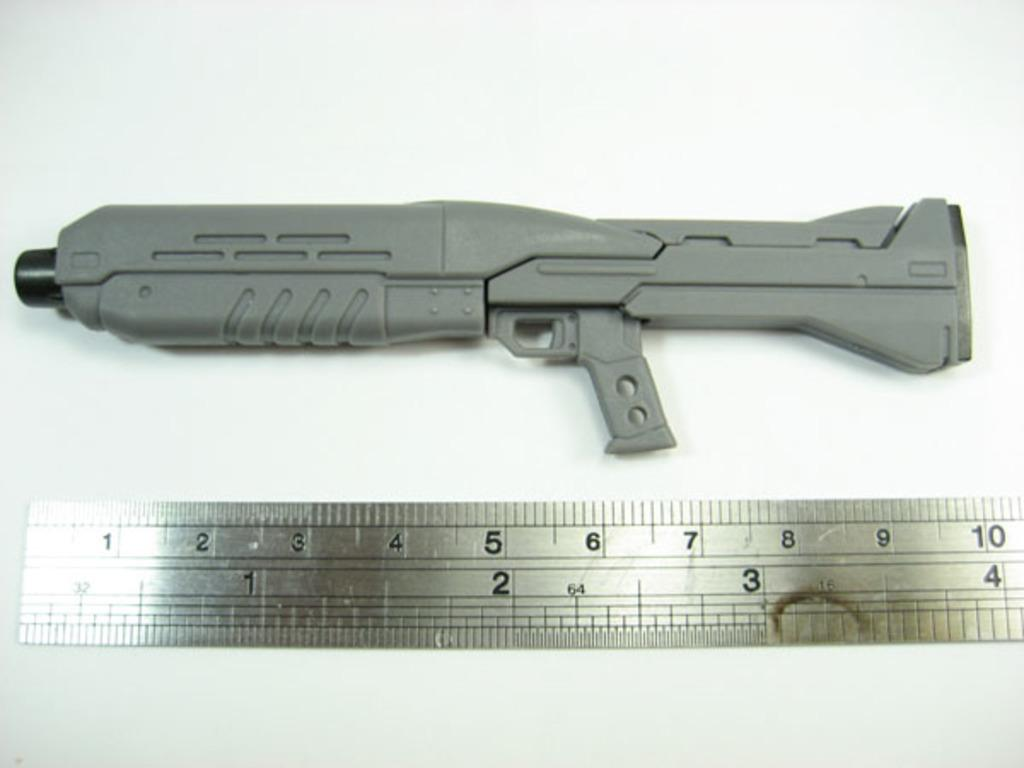<image>
Present a compact description of the photo's key features. a ruler with many digits on it including ten 